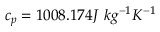<formula> <loc_0><loc_0><loc_500><loc_500>c _ { p } = 1 0 0 8 . 1 7 4 J \ k g ^ { - 1 } K ^ { - 1 }</formula> 